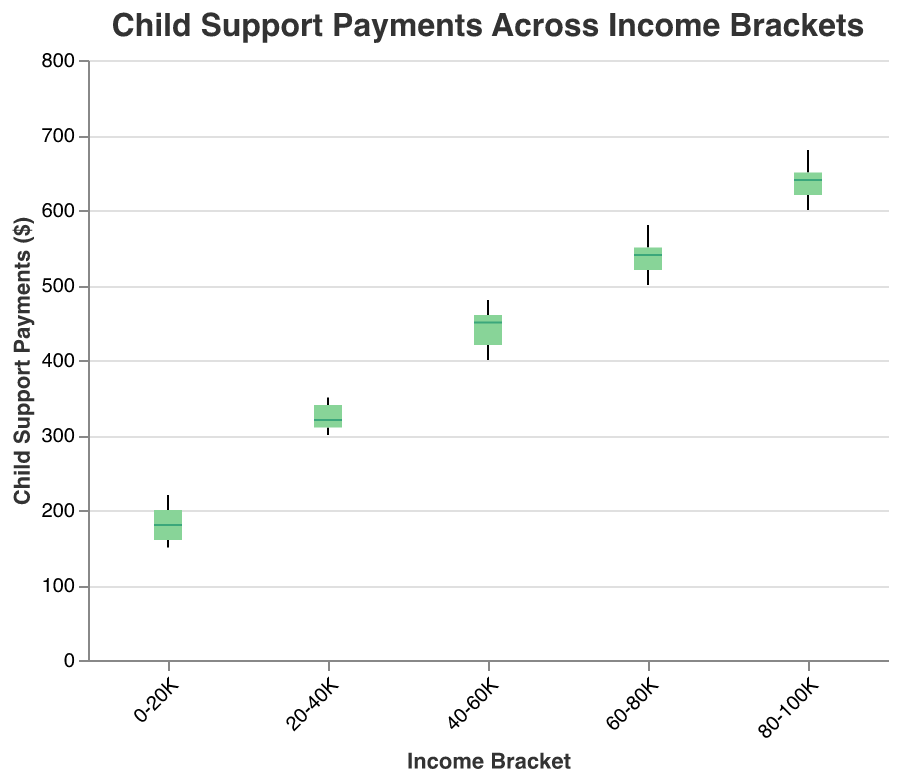What is the title of the plot? The title is prominently displayed at the top of the plot. By looking at this section of the figure, we can understand the main focus of the visualization.
Answer: Child Support Payments Across Income Brackets What are the income brackets displayed on the x-axis? The x-axis represents the different income brackets. By examining this axis, we can see the categories that are being compared.
Answer: 0-20K, 20-40K, 40-60K, 60-80K, 80-100K What is the range of child support payments for the income bracket 40-60K? The range of child support payments is shown by the extent of the whiskers in the box plot. For the 40-60K income bracket, we can see the minimum and maximum values.
Answer: 400 to 480 Which income bracket has the highest median child support payment? The median child support payment is indicated by the line inside the box. By comparing the median lines across different brackets, we can identify the highest one.
Answer: 80-100K Which income bracket shows the narrowest range of child support payments? The range is indicated by the length of the whiskers. By comparing the lengths across different brackets, we can determine the narrowest range.
Answer: 0-20K What is the median child support payment for the income bracket 20-40K? The median is represented by the line within the box for each income bracket. For the 20-40K bracket, we can identify this line to find the median.
Answer: 320 How does the range of child support payments for the 60-80K bracket compare to the 80-100K bracket? To compare ranges, we look at the whiskers of both brackets and see which one spans a greater interval.
Answer: The range for 60-80K is narrower than 80-100K Which income bracket has the largest variation in child support payments? By examining the length of the whiskers (the total range), we can identify which bracket has the largest variation.
Answer: 80-100K How does the median payment for the 60-80K bracket compare to the median payment for the 0-20K bracket? To compare the medians, we look at the lines inside the boxes for the two brackets and see which one is higher or lower.
Answer: The median for 60-80K is higher than for 0-20K What is the interquartile range (IQR) for the 60-80K income bracket? The IQR is the range between the first quartile (bottom of the box) and the third quartile (top of the box). By estimating these points from the box plot, we can calculate the IQR.
Answer: Approximately 500 to 550 (IQR = 50) 